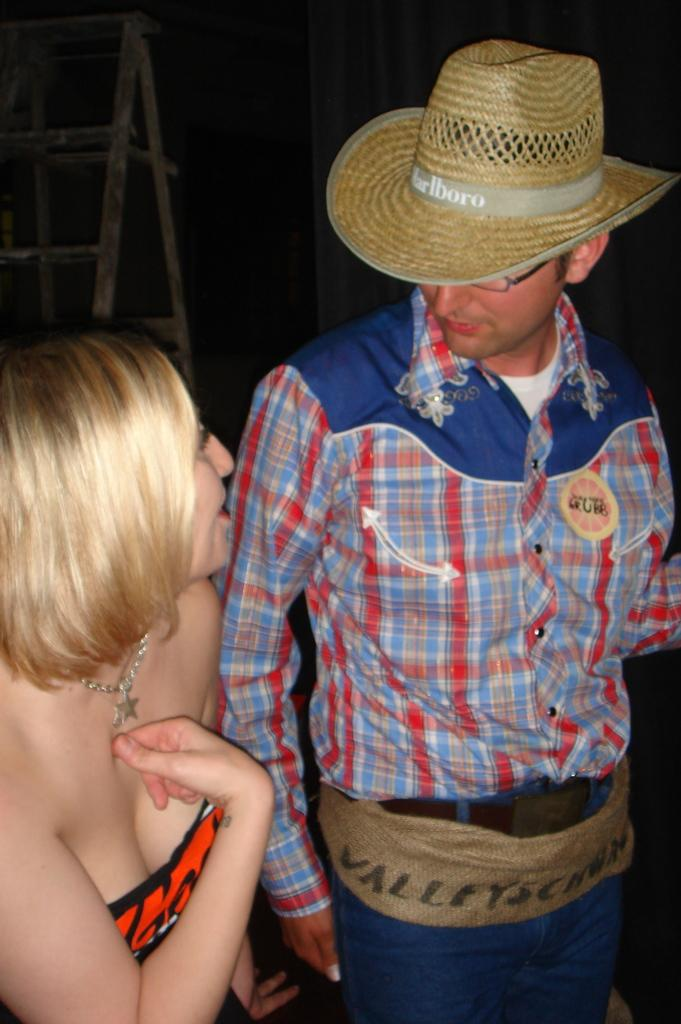What is the man in the image wearing? The man is wearing a shirt, blue jeans, and a brown hat. What is the woman in the image wearing? The woman is wearing a red dress and some jewelry. Can you describe any objects or structures in the background of the image? There is a ladder in the background of the image. What type of shade is provided by the moon in the image? There is no moon present in the image, so there is no shade provided by the moon. Is there a swing visible in the image? No, there is no swing visible in the image. 